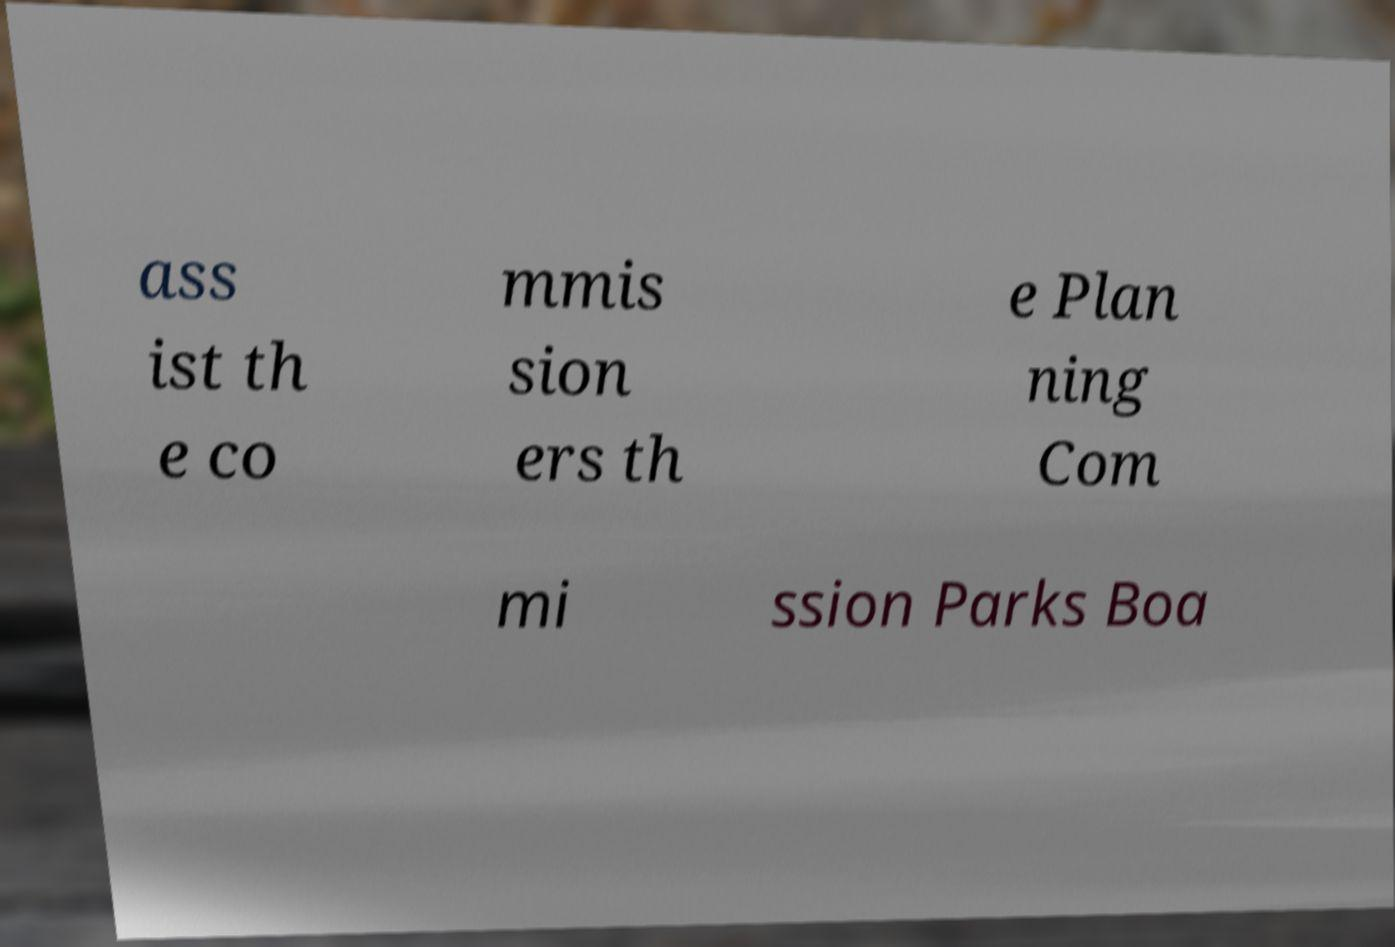Could you assist in decoding the text presented in this image and type it out clearly? ass ist th e co mmis sion ers th e Plan ning Com mi ssion Parks Boa 